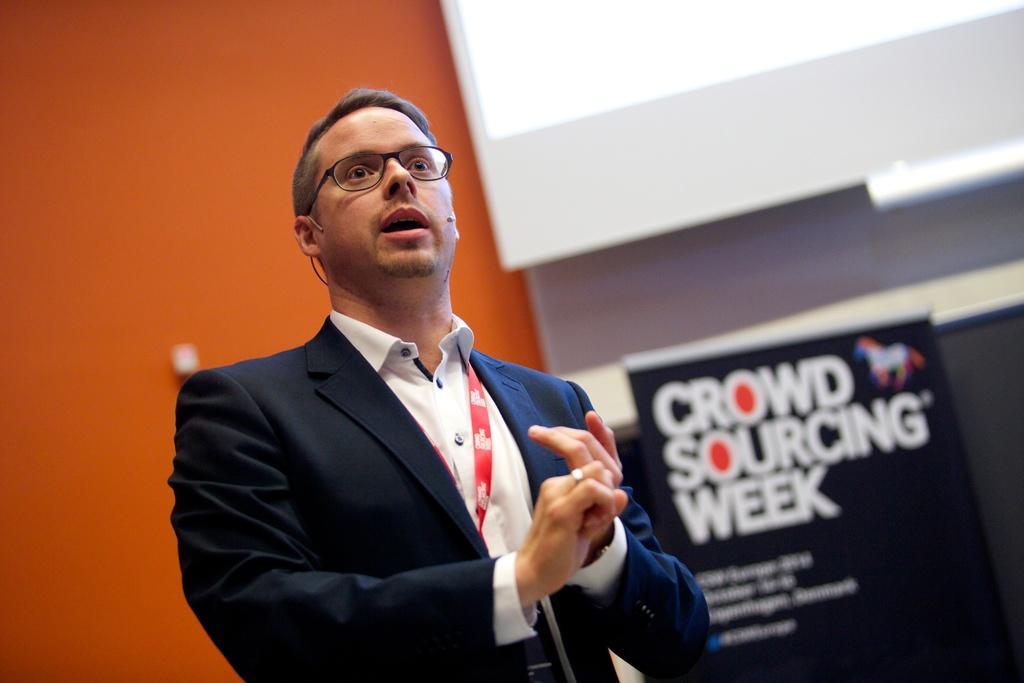How would you summarize this image in a sentence or two? In the picture I can see a man is standing. The man is wearing spectacles, a microphone, an ID card, a shirt and a coat. In the background I can see a wall and a banner on which there is something written on it. 